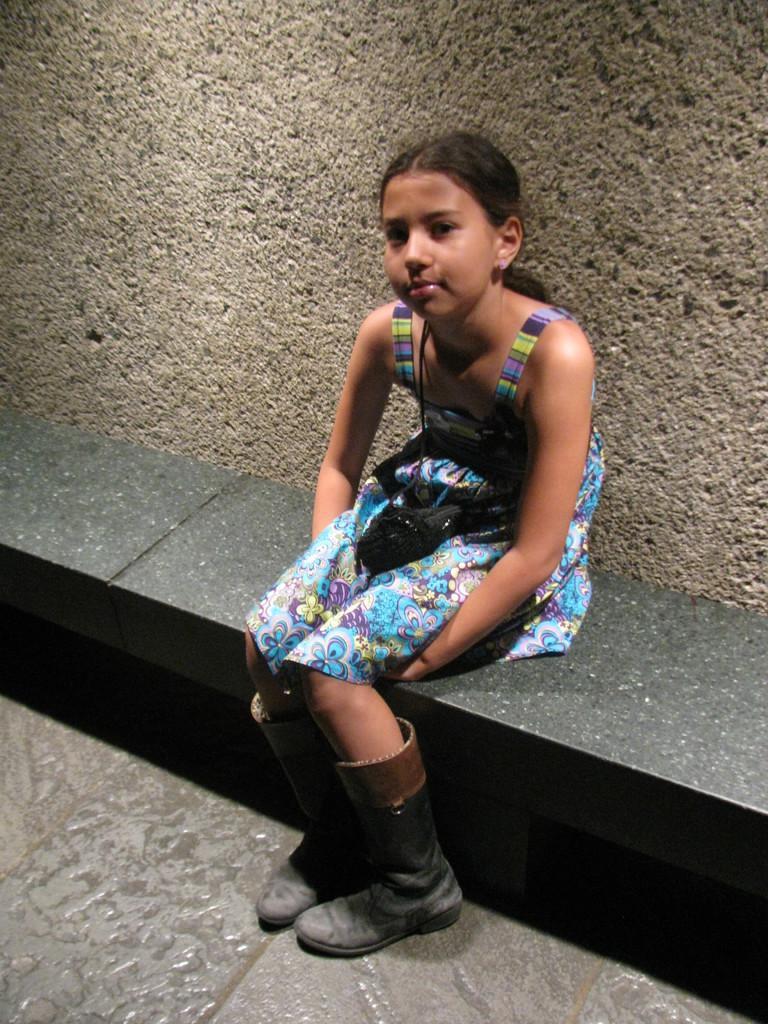Describe this image in one or two sentences. In this image we can see a kid wearing multi color dress and black color boots sitting on surface and in the background of the image there is a wall. 